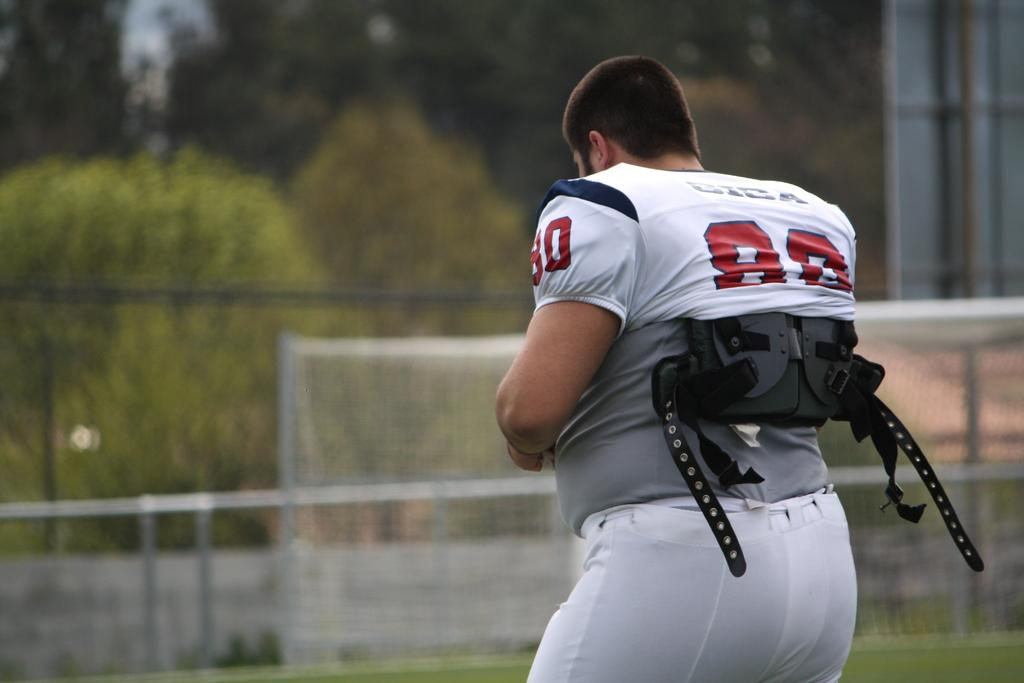Who is the main subject in the foreground of the image? There is a man in the foreground of the image. What is the man wearing in the image? The man is wearing a jacket in the image. What can be seen in the background of the image? There is a goal net, grass, railing, trees, and a board in the background of the image. What type of grain can be seen growing in the image? There is no grain visible in the image; it features a man in the foreground and various elements in the background, including a goal net, grass, railing, trees, and a board. 